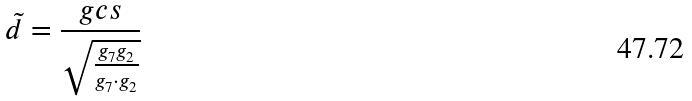<formula> <loc_0><loc_0><loc_500><loc_500>\tilde { d } = \frac { g c s } { \sqrt { \frac { g _ { 7 } g _ { 2 } } { g _ { 7 } \cdot g _ { 2 } } } }</formula> 